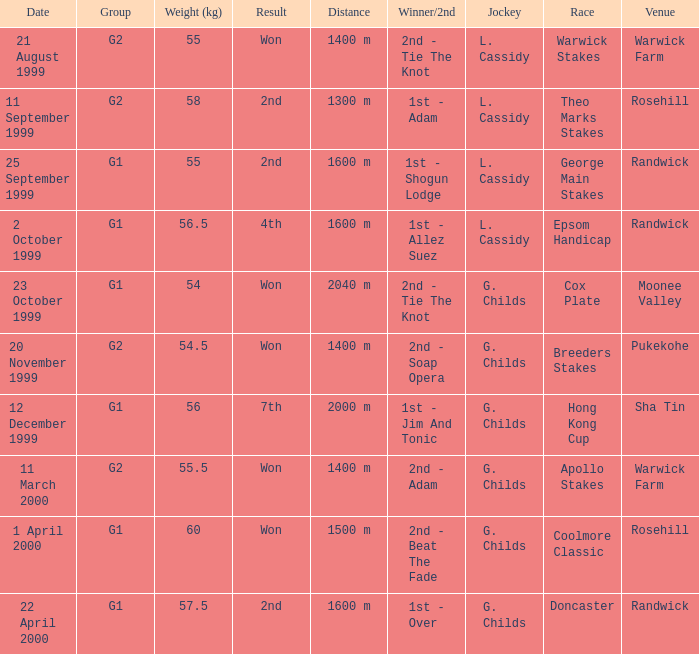How man teams had a total weight of 57.5? 1.0. 